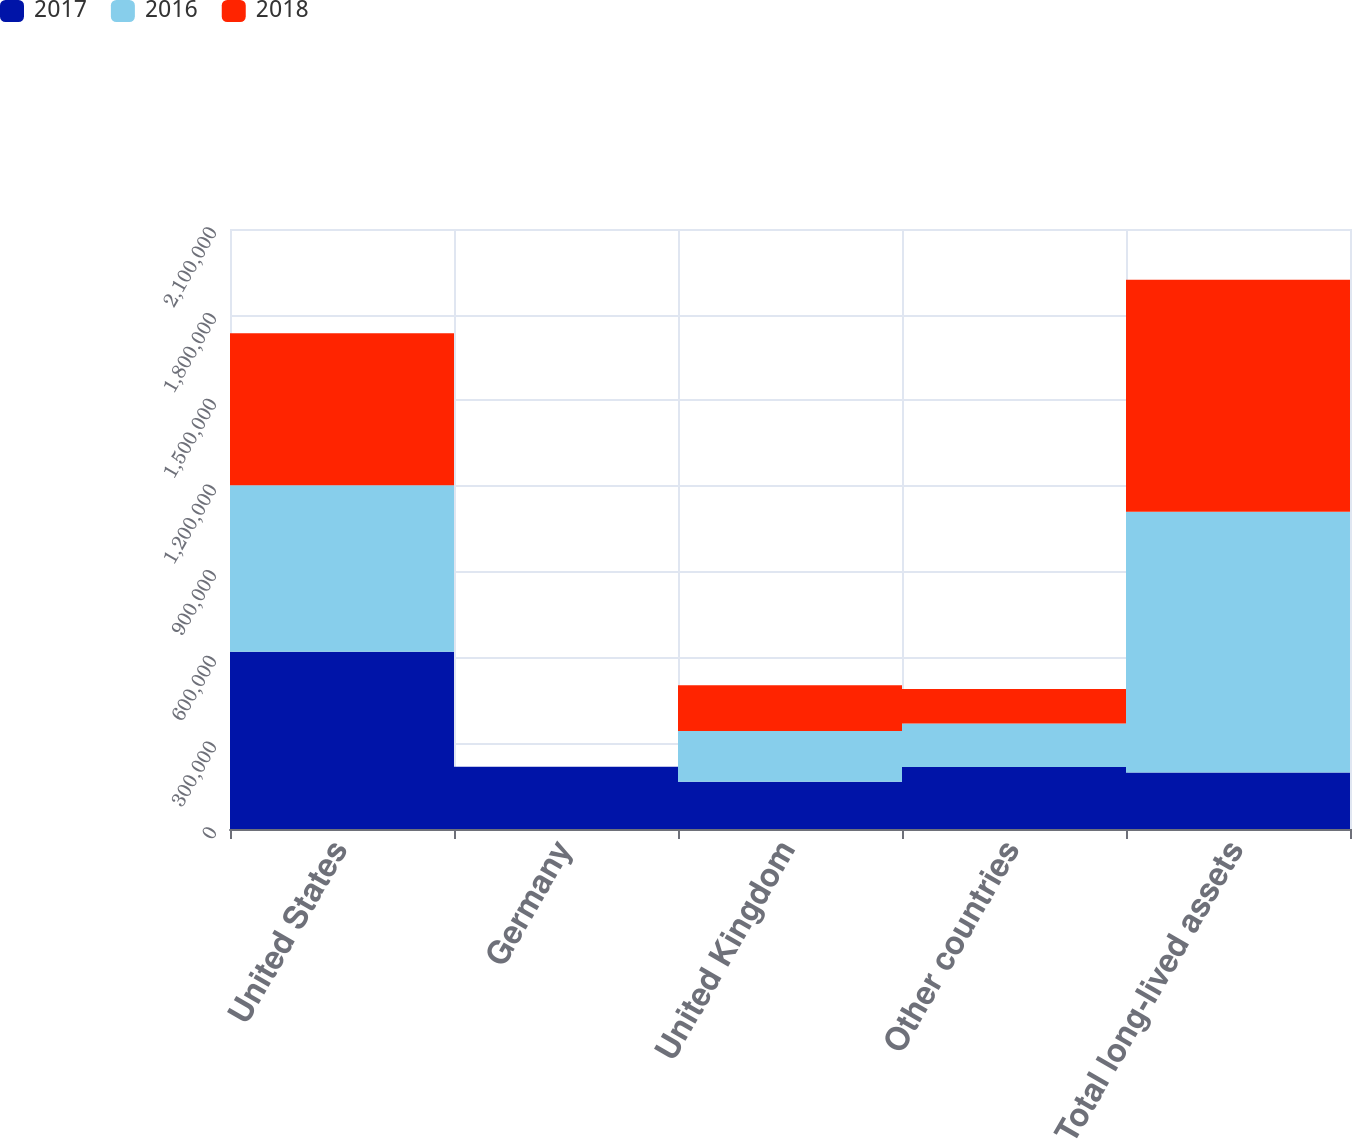<chart> <loc_0><loc_0><loc_500><loc_500><stacked_bar_chart><ecel><fcel>United States<fcel>Germany<fcel>United Kingdom<fcel>Other countries<fcel>Total long-lived assets<nl><fcel>2017<fcel>620125<fcel>217476<fcel>165145<fcel>217416<fcel>197718<nl><fcel>2016<fcel>583236<fcel>41<fcel>178021<fcel>151791<fcel>913089<nl><fcel>2018<fcel>531425<fcel>19<fcel>159689<fcel>120443<fcel>811576<nl></chart> 